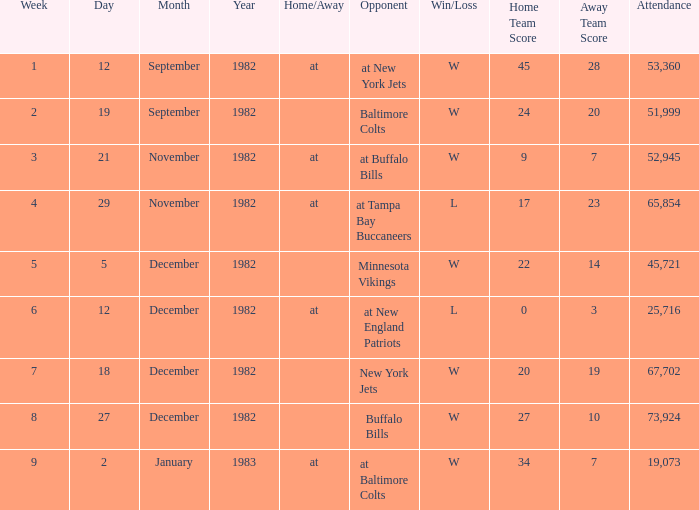What is the result of the game with an attendance greater than 67,702? W 27–10. 